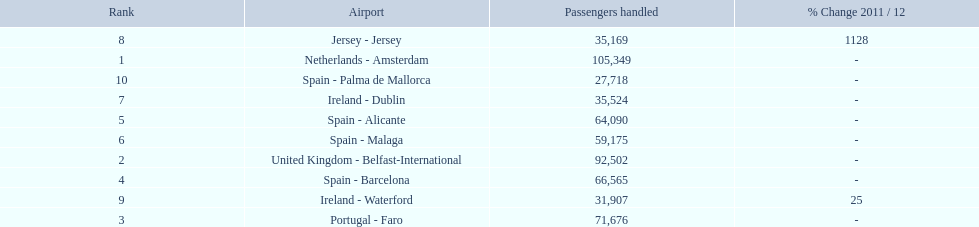What are all of the airports? Netherlands - Amsterdam, United Kingdom - Belfast-International, Portugal - Faro, Spain - Barcelona, Spain - Alicante, Spain - Malaga, Ireland - Dublin, Jersey - Jersey, Ireland - Waterford, Spain - Palma de Mallorca. How many passengers have they handled? 105,349, 92,502, 71,676, 66,565, 64,090, 59,175, 35,524, 35,169, 31,907, 27,718. And which airport has handled the most passengers? Netherlands - Amsterdam. 